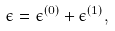<formula> <loc_0><loc_0><loc_500><loc_500>\epsilon = \epsilon ^ { ( 0 ) } + \epsilon ^ { ( 1 ) } ,</formula> 